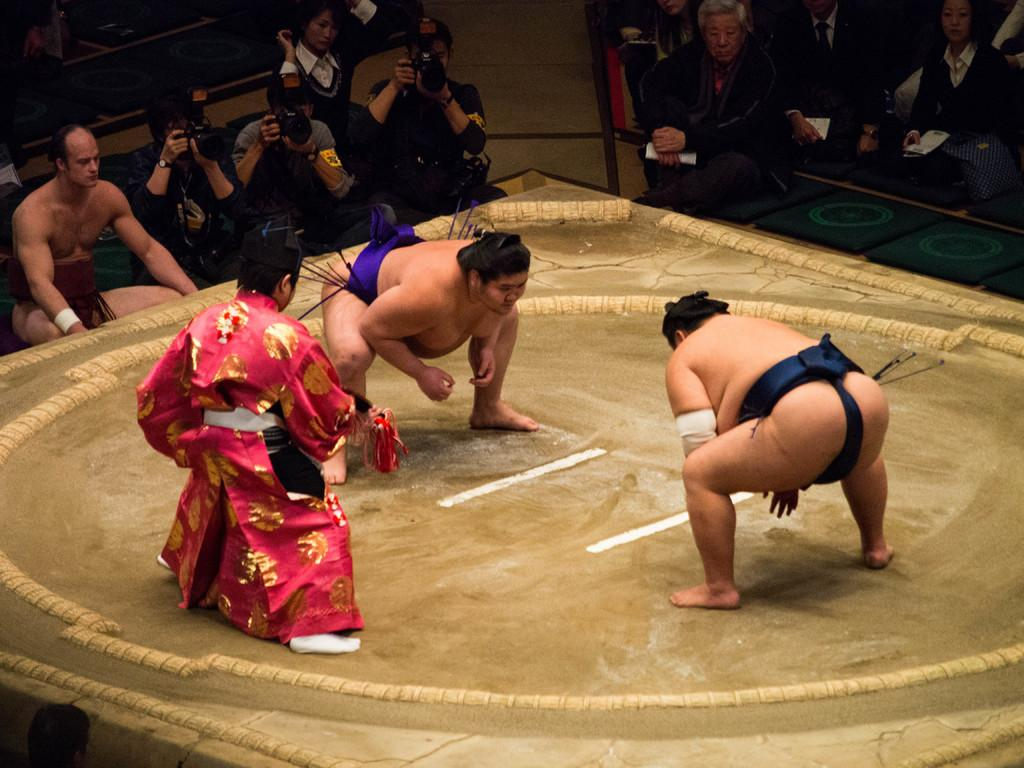How many people are in the group that is visible in the image? There is a group of people in the image, but the exact number is not specified. What is the appearance of one person in the group? One person in the group is wearing a red and black color dress. What can be seen in the background of the image? In the background, there are people sitting. What are some of the people in the background holding? Some of the people in the background are holding cameras. What type of punishment is being handed out in the image? There is no indication of punishment in the image; it features a group of people and people sitting in the background. What is the tax rate for the event in the image? There is no mention of an event or tax rate in the image. 